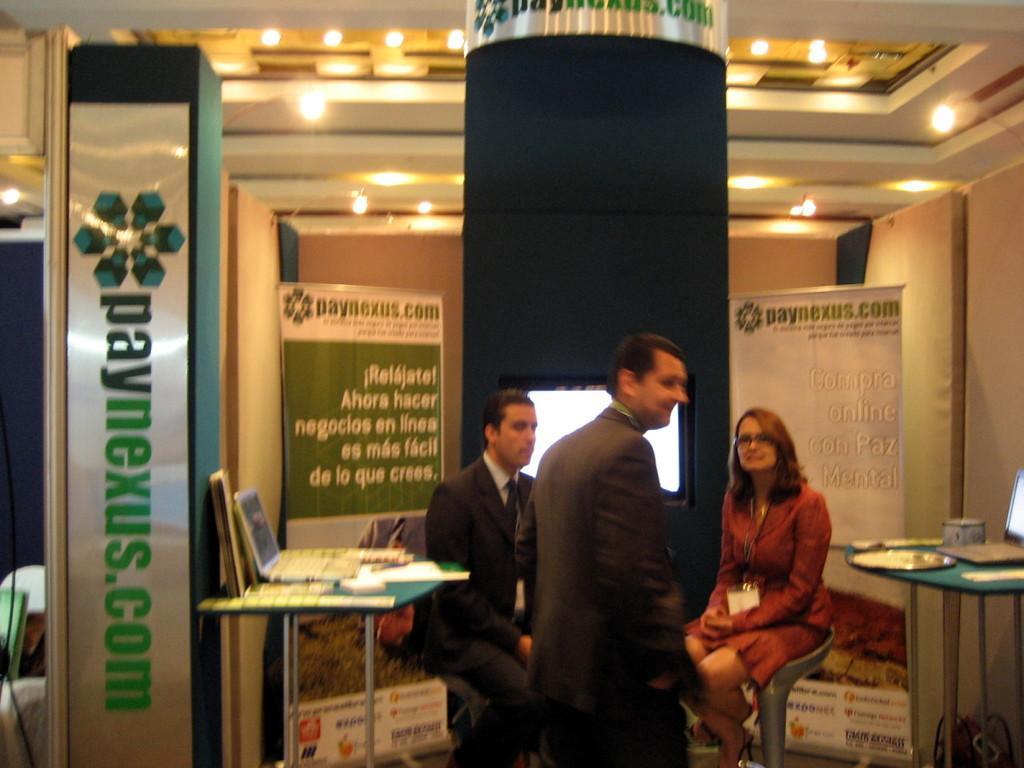Can you describe this image briefly? In the image we can see there are people who are sitting on chair and a person is standing here. On the table there is a laptop and at the back there are banners. 